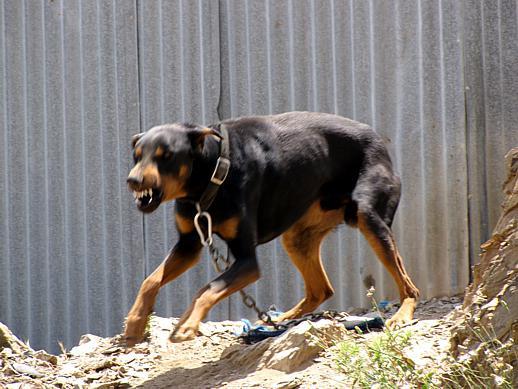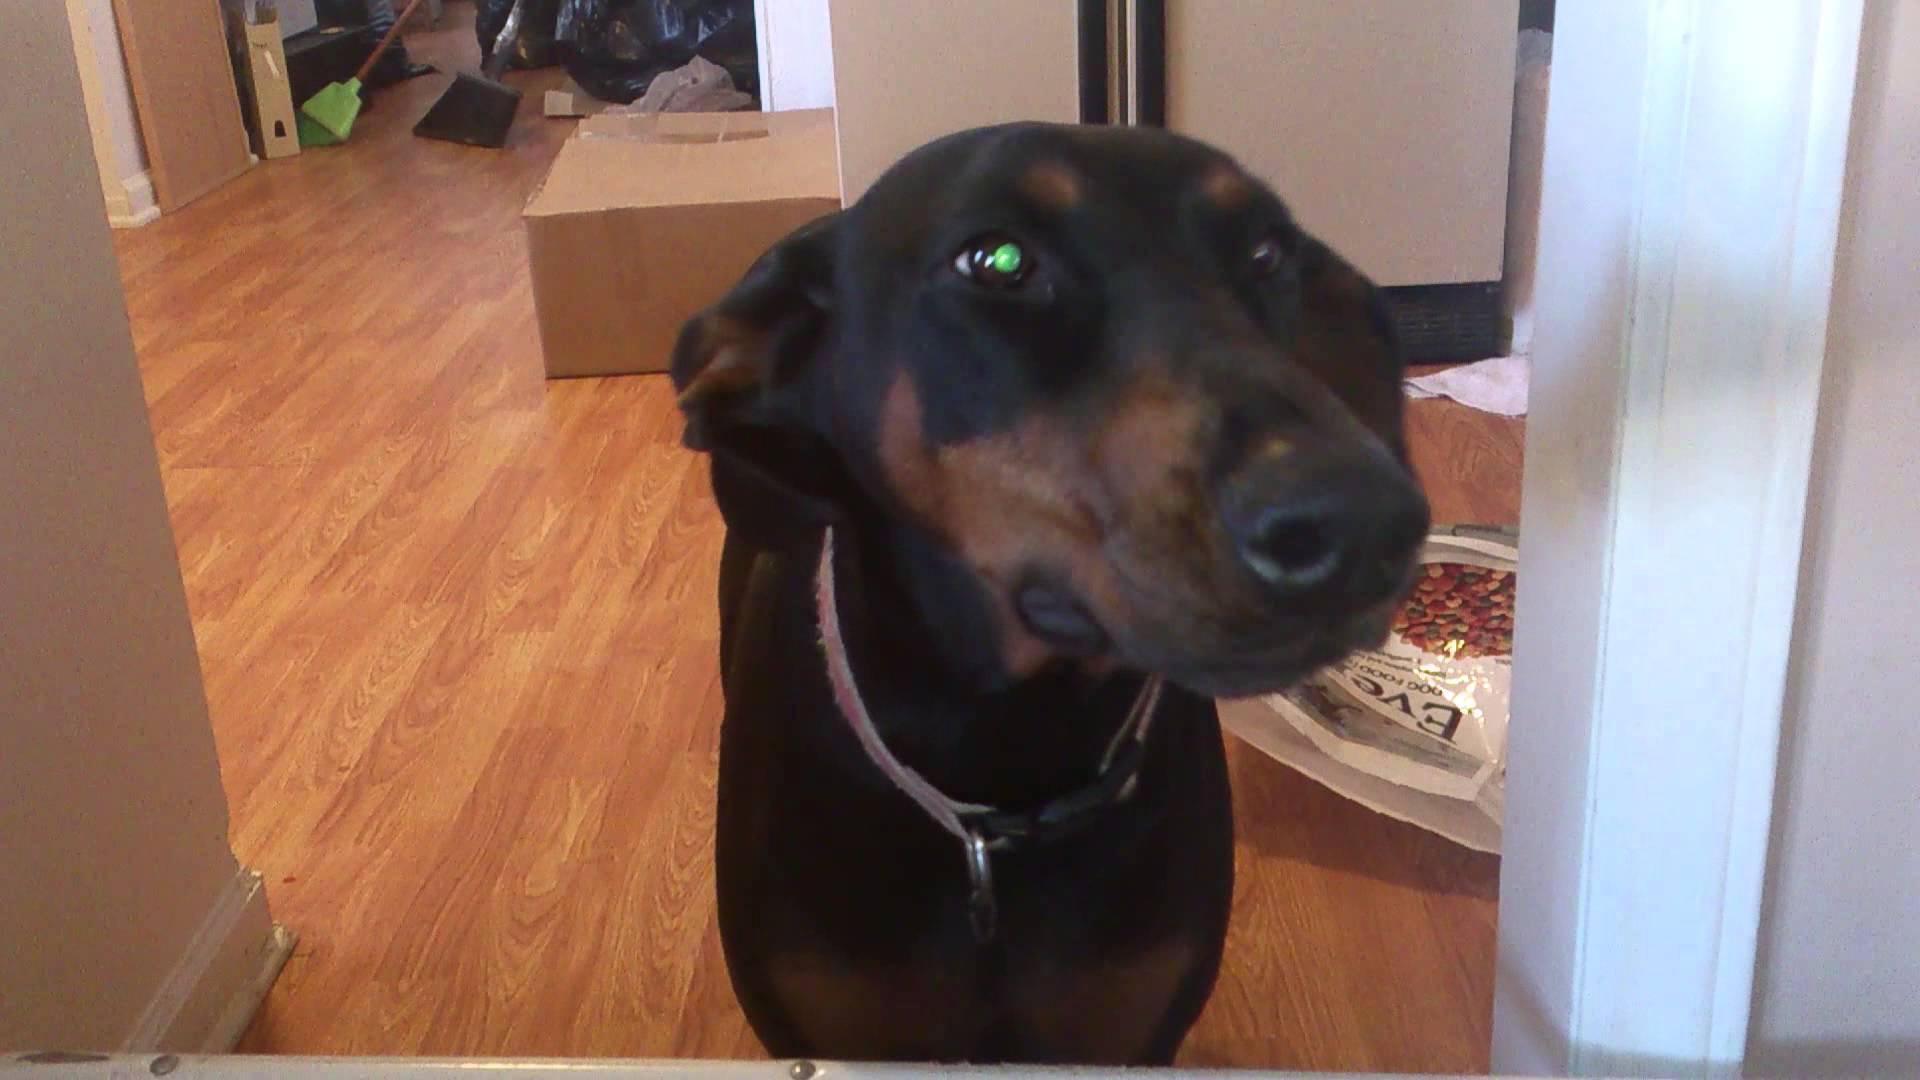The first image is the image on the left, the second image is the image on the right. Considering the images on both sides, is "Both dogs are indoors." valid? Answer yes or no. No. The first image is the image on the left, the second image is the image on the right. Analyze the images presented: Is the assertion "The right image contains a black and brown dog inside on a wooden floor." valid? Answer yes or no. Yes. 